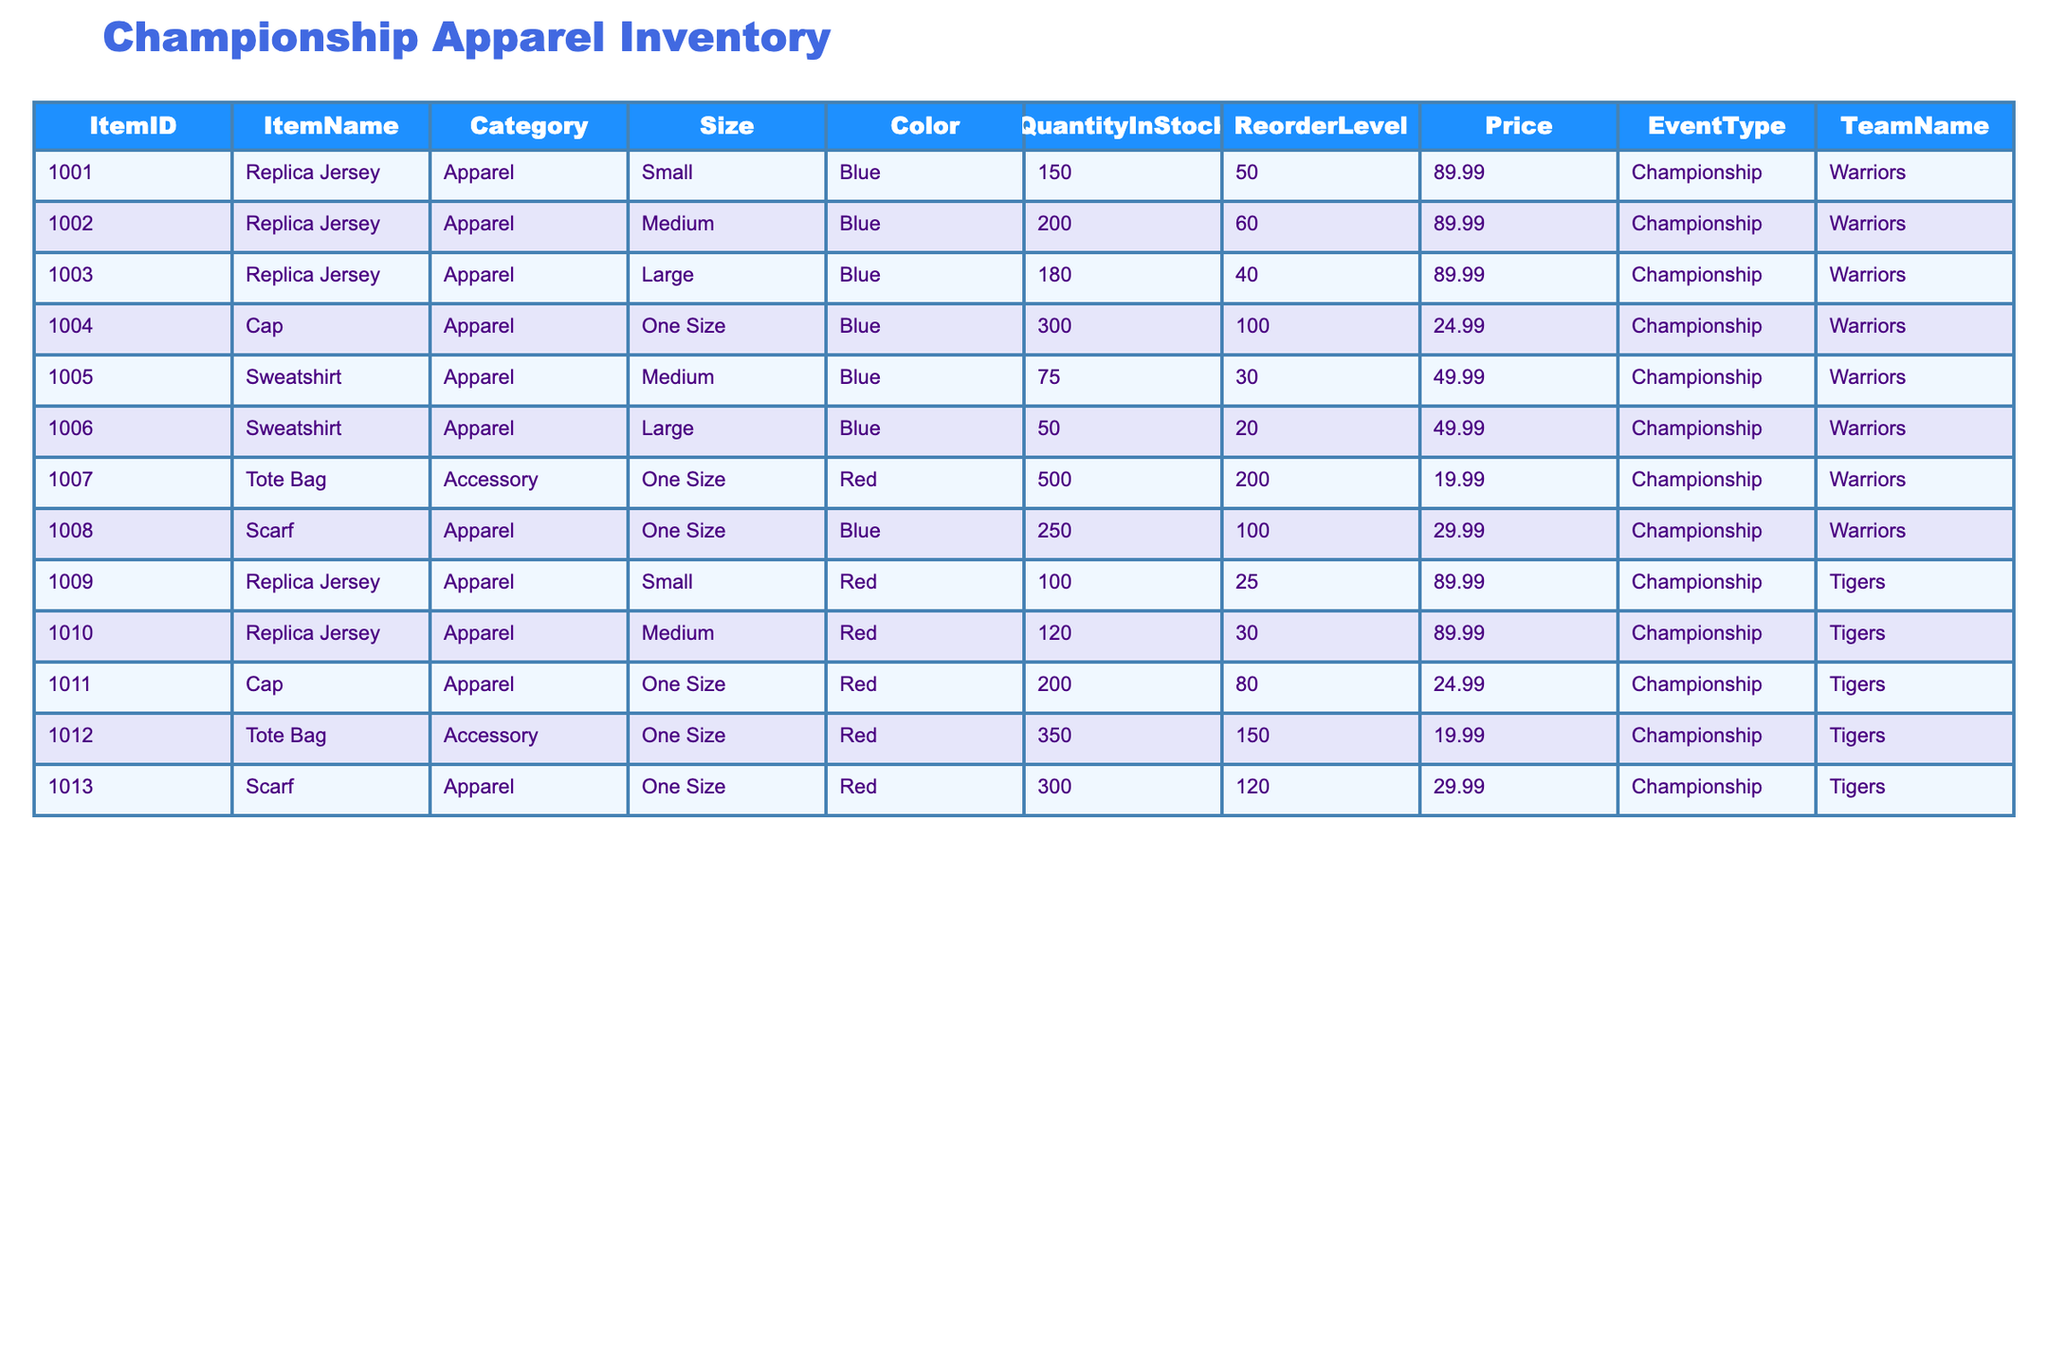What is the quantity in stock for the Medium Replica Jersey from the Warriors? Looking at the table, we find the row with the Medium Replica Jersey for the Warriors. In that row, the quantity in stock is stated as 200.
Answer: 200 What is the price of a Scarf for the Tigers? The table shows the item for the Scarf in the row for the Tigers. It lists the price of the Scarf as 29.99.
Answer: 29.99 How many total Replica Jerseys are available for both teams combined? To find the total, we need to sum the quantities of Replica Jerseys for each team. For the Warriors: Small (150) + Medium (200) + Large (180) = 530. For the Tigers: Small (100) + Medium (120) = 220. Combining these gives 530 + 220 = 750.
Answer: 750 Is there a Reorder Level listed for the Cap in Red? In the row for the Red Cap, the Reorder Level is specified as 80. Therefore, the statement is true, as there is indeed a Reorder Level for that item.
Answer: Yes What is the average quantity in stock for Sweatshirts across both teams? For the Warriors, the Sweatshirt quantity is Medium (75) and Large (50) totaling 125. For the Tigers, no Sweatshirts are listed. Therefore, the average is 125 / 2 = 62.5.
Answer: 62.5 What team has more total items in stock for Blue Apparel? Count the Blue Apparel items for the Warriors: Replica Jerseys (150 + 200 + 180 = 530), Cap (300), Sweatshirt (75 + 50 = 125), Scarf (250). Total for Warriors = 530 + 300 + 125 + 250 = 1205. The Tigers have no blue items. Hence, the Warriors clearly have more stock.
Answer: Warriors How many total Cap items are there across both teams? For the Warriors, the Cap quantity is 300. For the Tigers, it is 200. Adding them gives us 300 + 200 = 500 Cap items in total.
Answer: 500 What is the total revenue generated if all available Tote Bags are sold for both teams? For the Warriors, the Tote Bag quantity is 500 at a price of 19.99, resulting in 500 * 19.99 = 9995. For the Tigers, it is 350 at the same price, yielding 350 * 19.99 = 6996. Combined total revenue is 9995 + 6996 = 16991.
Answer: 16991 